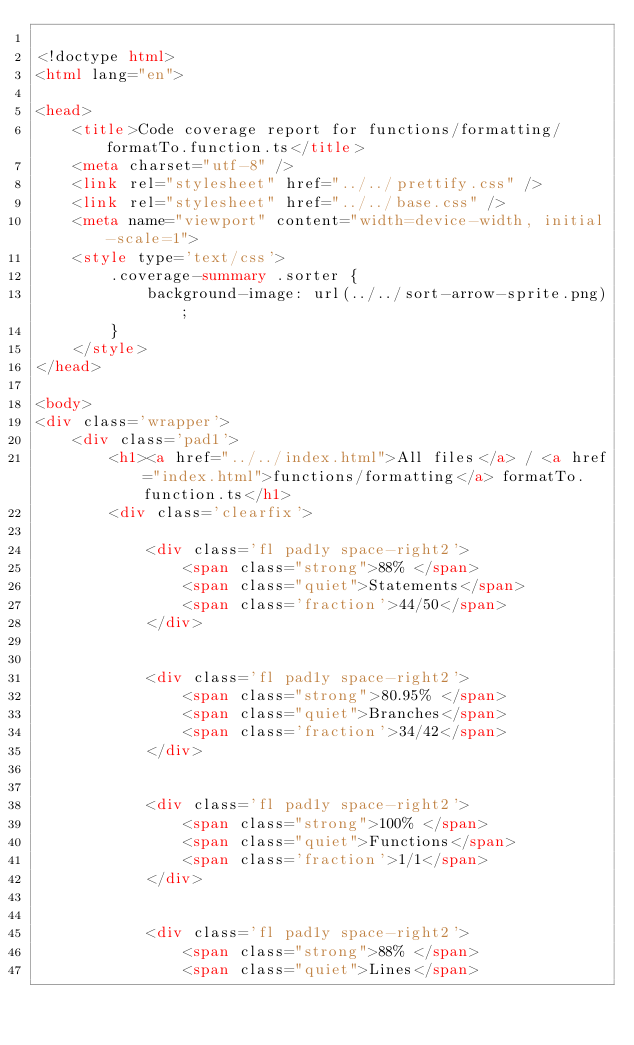<code> <loc_0><loc_0><loc_500><loc_500><_HTML_>
<!doctype html>
<html lang="en">

<head>
    <title>Code coverage report for functions/formatting/formatTo.function.ts</title>
    <meta charset="utf-8" />
    <link rel="stylesheet" href="../../prettify.css" />
    <link rel="stylesheet" href="../../base.css" />
    <meta name="viewport" content="width=device-width, initial-scale=1">
    <style type='text/css'>
        .coverage-summary .sorter {
            background-image: url(../../sort-arrow-sprite.png);
        }
    </style>
</head>
    
<body>
<div class='wrapper'>
    <div class='pad1'>
        <h1><a href="../../index.html">All files</a> / <a href="index.html">functions/formatting</a> formatTo.function.ts</h1>
        <div class='clearfix'>
            
            <div class='fl pad1y space-right2'>
                <span class="strong">88% </span>
                <span class="quiet">Statements</span>
                <span class='fraction'>44/50</span>
            </div>
        
            
            <div class='fl pad1y space-right2'>
                <span class="strong">80.95% </span>
                <span class="quiet">Branches</span>
                <span class='fraction'>34/42</span>
            </div>
        
            
            <div class='fl pad1y space-right2'>
                <span class="strong">100% </span>
                <span class="quiet">Functions</span>
                <span class='fraction'>1/1</span>
            </div>
        
            
            <div class='fl pad1y space-right2'>
                <span class="strong">88% </span>
                <span class="quiet">Lines</span></code> 